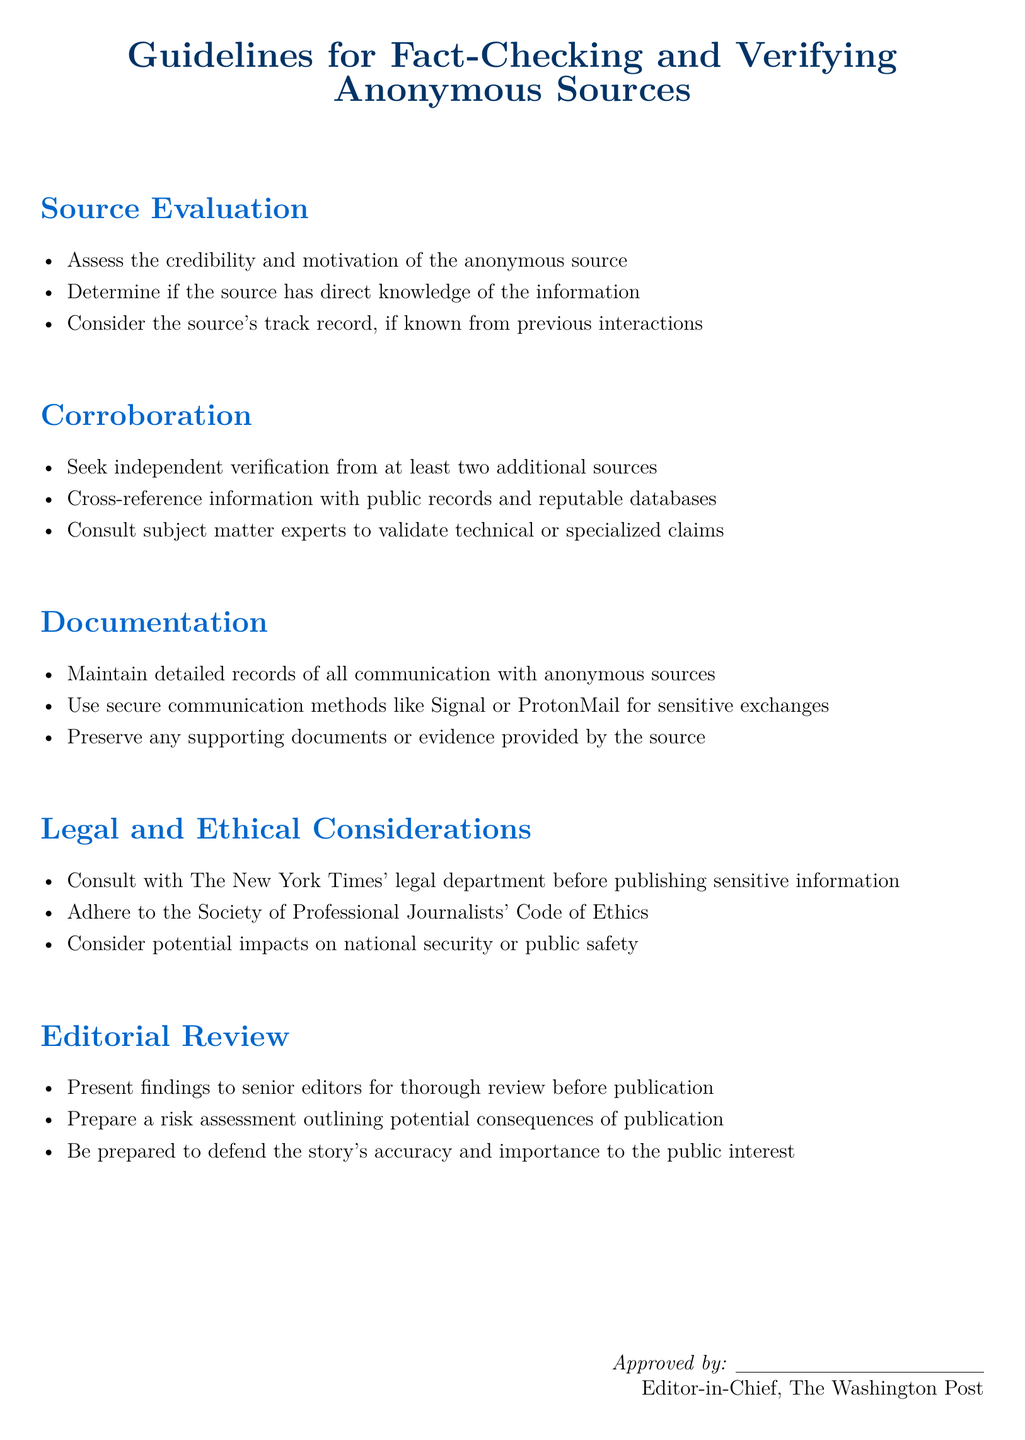What is the title of the document? The title of the document is prominently displayed at the center and indicates the main topic it addresses.
Answer: Guidelines for Fact-Checking and Verifying Anonymous Sources How many sections are in the document? The document contains five distinct sections, each covering an important aspect of fact-checking and verification.
Answer: 5 What is one method suggested for secure communication? The document provides examples of secure communication methods that journalists can use to protect sensitive exchanges.
Answer: Signal Who should be consulted before publishing sensitive information? The guidelines recommend specific consultation for legal advice regarding the publication of sensitive details.
Answer: The New York Times' legal department What should be preserved alongside communication records? The document advises maintaining additional documents that support the information provided by anonymous sources.
Answer: Supporting documents How many independent verifications should be sought? The guidelines state a specific number of independent sources journalists should verify information with for accuracy.
Answer: At least two What is required before publication in the editorial review process? The document specifies a key action that should be taken prior to publishing a story to ensure thorough review and risk assessment.
Answer: Present findings to senior editors According to the guidelines, whose ethics should be adhered to? The document indicates an established organization whose ethical standards should guide journalists in their reporting practices.
Answer: Society of Professional Journalists What should be prepared during the editorial review? The document highlights the necessity of creating a specific document to assess potential consequences before publication.
Answer: Risk assessment 